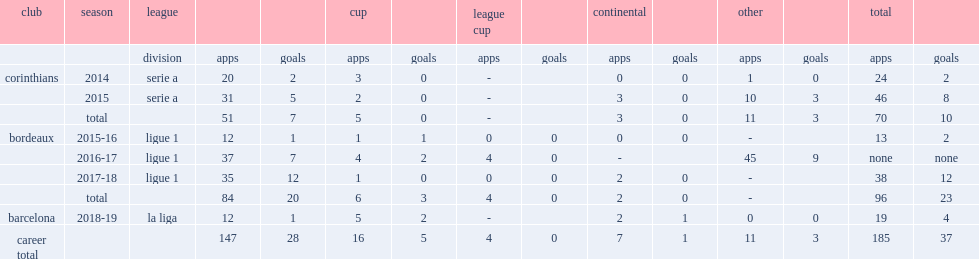How many goals did malcom score for bordeaux totally? 23.0. 